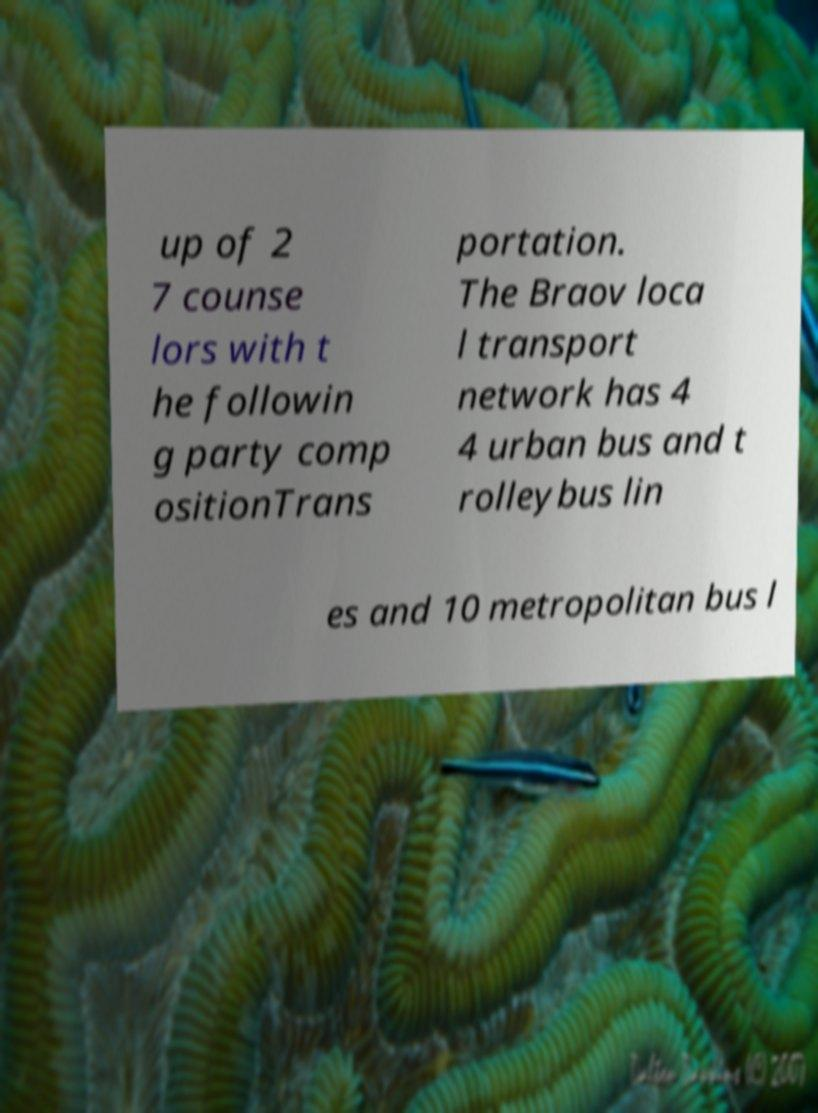Please read and relay the text visible in this image. What does it say? up of 2 7 counse lors with t he followin g party comp ositionTrans portation. The Braov loca l transport network has 4 4 urban bus and t rolleybus lin es and 10 metropolitan bus l 